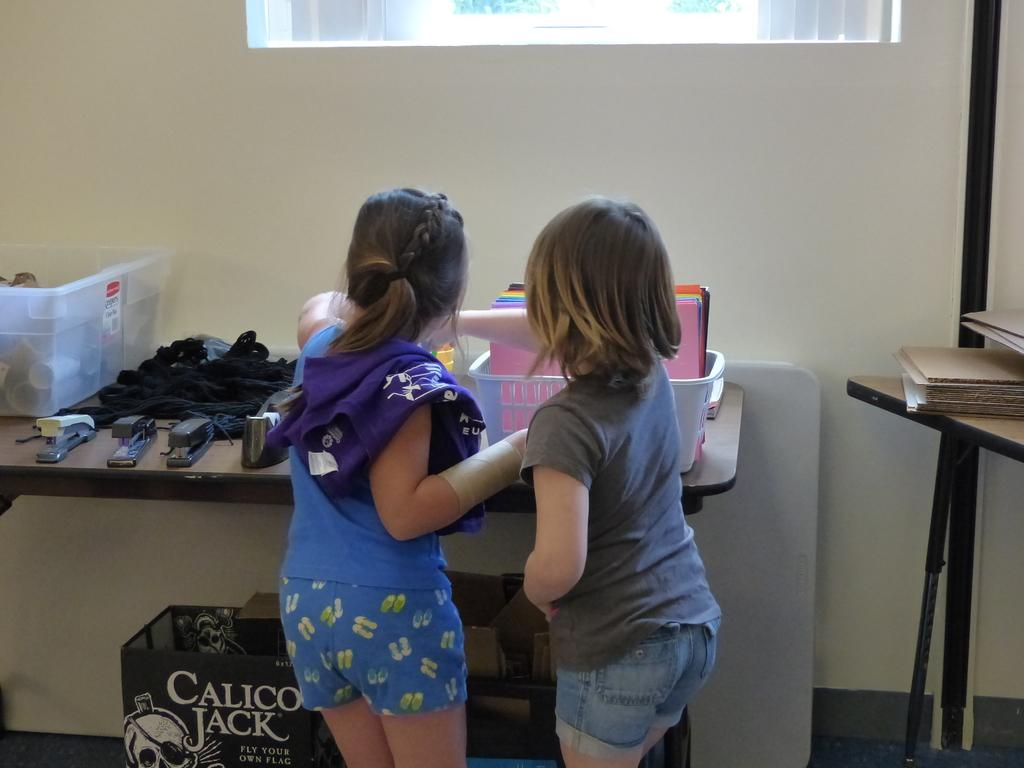<image>
Provide a brief description of the given image. A Calico Jack box is sitting underneath the table. 